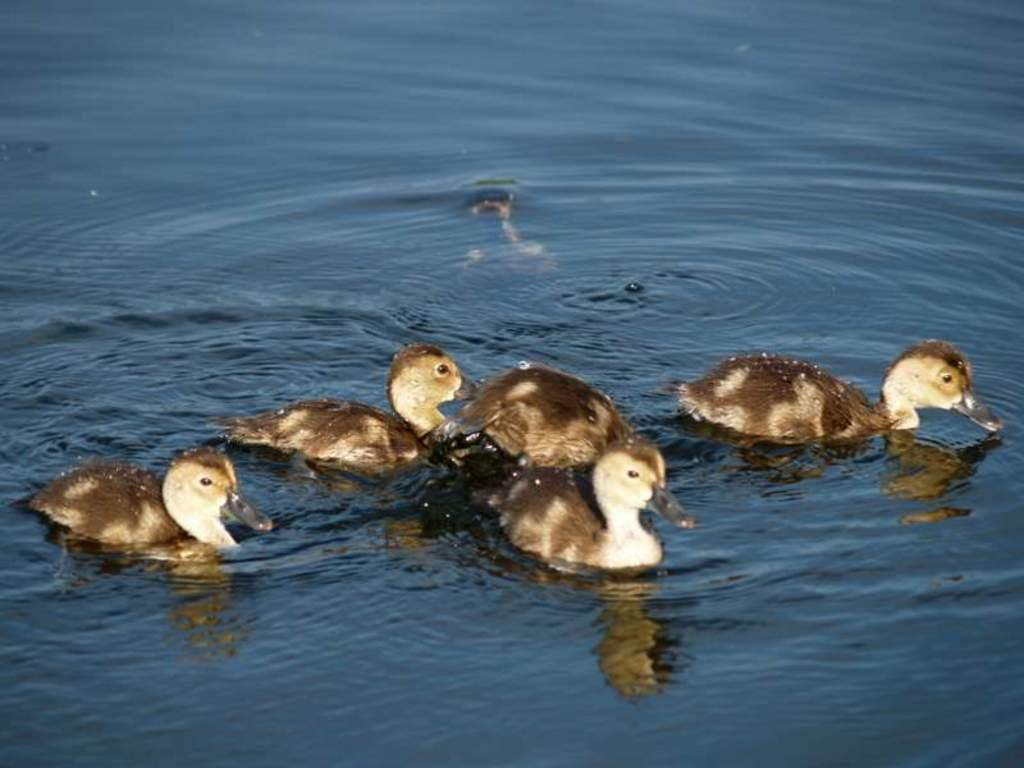What animals are present in the image? There is a group of ducks in the image. Where are the ducks located? The ducks are present in the water. What type of cookware is visible in the image? There is no cookware present in the image; it features a group of ducks in the water. What type of tree branch can be seen in the image? There is no tree branch present in the image; it features a group of ducks in the water. 